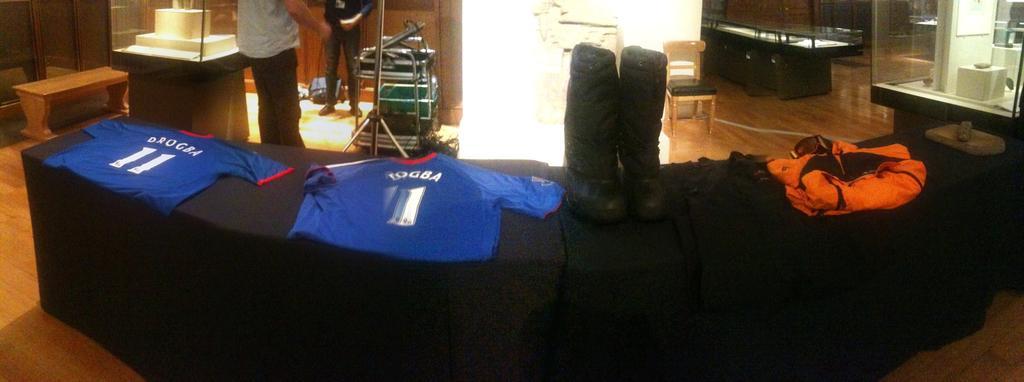In one or two sentences, can you explain what this image depicts? In this image I can see two people and two jerseys. I can also see few chairs and benches. 